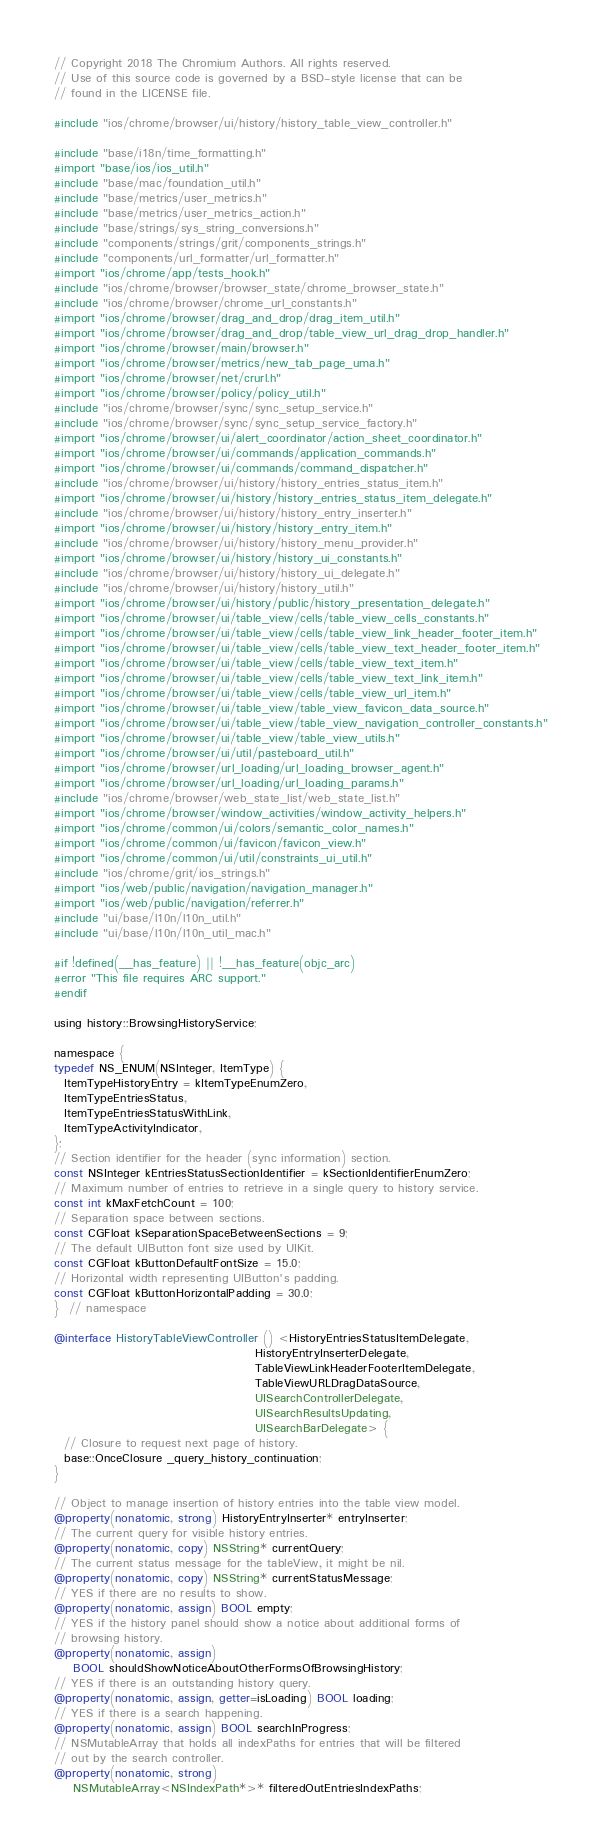<code> <loc_0><loc_0><loc_500><loc_500><_ObjectiveC_>// Copyright 2018 The Chromium Authors. All rights reserved.
// Use of this source code is governed by a BSD-style license that can be
// found in the LICENSE file.

#include "ios/chrome/browser/ui/history/history_table_view_controller.h"

#include "base/i18n/time_formatting.h"
#import "base/ios/ios_util.h"
#include "base/mac/foundation_util.h"
#include "base/metrics/user_metrics.h"
#include "base/metrics/user_metrics_action.h"
#include "base/strings/sys_string_conversions.h"
#include "components/strings/grit/components_strings.h"
#include "components/url_formatter/url_formatter.h"
#import "ios/chrome/app/tests_hook.h"
#include "ios/chrome/browser/browser_state/chrome_browser_state.h"
#include "ios/chrome/browser/chrome_url_constants.h"
#import "ios/chrome/browser/drag_and_drop/drag_item_util.h"
#import "ios/chrome/browser/drag_and_drop/table_view_url_drag_drop_handler.h"
#import "ios/chrome/browser/main/browser.h"
#import "ios/chrome/browser/metrics/new_tab_page_uma.h"
#import "ios/chrome/browser/net/crurl.h"
#import "ios/chrome/browser/policy/policy_util.h"
#include "ios/chrome/browser/sync/sync_setup_service.h"
#include "ios/chrome/browser/sync/sync_setup_service_factory.h"
#import "ios/chrome/browser/ui/alert_coordinator/action_sheet_coordinator.h"
#import "ios/chrome/browser/ui/commands/application_commands.h"
#import "ios/chrome/browser/ui/commands/command_dispatcher.h"
#include "ios/chrome/browser/ui/history/history_entries_status_item.h"
#import "ios/chrome/browser/ui/history/history_entries_status_item_delegate.h"
#include "ios/chrome/browser/ui/history/history_entry_inserter.h"
#import "ios/chrome/browser/ui/history/history_entry_item.h"
#include "ios/chrome/browser/ui/history/history_menu_provider.h"
#import "ios/chrome/browser/ui/history/history_ui_constants.h"
#include "ios/chrome/browser/ui/history/history_ui_delegate.h"
#include "ios/chrome/browser/ui/history/history_util.h"
#import "ios/chrome/browser/ui/history/public/history_presentation_delegate.h"
#import "ios/chrome/browser/ui/table_view/cells/table_view_cells_constants.h"
#import "ios/chrome/browser/ui/table_view/cells/table_view_link_header_footer_item.h"
#import "ios/chrome/browser/ui/table_view/cells/table_view_text_header_footer_item.h"
#import "ios/chrome/browser/ui/table_view/cells/table_view_text_item.h"
#import "ios/chrome/browser/ui/table_view/cells/table_view_text_link_item.h"
#import "ios/chrome/browser/ui/table_view/cells/table_view_url_item.h"
#import "ios/chrome/browser/ui/table_view/table_view_favicon_data_source.h"
#import "ios/chrome/browser/ui/table_view/table_view_navigation_controller_constants.h"
#import "ios/chrome/browser/ui/table_view/table_view_utils.h"
#import "ios/chrome/browser/ui/util/pasteboard_util.h"
#import "ios/chrome/browser/url_loading/url_loading_browser_agent.h"
#import "ios/chrome/browser/url_loading/url_loading_params.h"
#include "ios/chrome/browser/web_state_list/web_state_list.h"
#import "ios/chrome/browser/window_activities/window_activity_helpers.h"
#import "ios/chrome/common/ui/colors/semantic_color_names.h"
#import "ios/chrome/common/ui/favicon/favicon_view.h"
#import "ios/chrome/common/ui/util/constraints_ui_util.h"
#include "ios/chrome/grit/ios_strings.h"
#import "ios/web/public/navigation/navigation_manager.h"
#import "ios/web/public/navigation/referrer.h"
#include "ui/base/l10n/l10n_util.h"
#include "ui/base/l10n/l10n_util_mac.h"

#if !defined(__has_feature) || !__has_feature(objc_arc)
#error "This file requires ARC support."
#endif

using history::BrowsingHistoryService;

namespace {
typedef NS_ENUM(NSInteger, ItemType) {
  ItemTypeHistoryEntry = kItemTypeEnumZero,
  ItemTypeEntriesStatus,
  ItemTypeEntriesStatusWithLink,
  ItemTypeActivityIndicator,
};
// Section identifier for the header (sync information) section.
const NSInteger kEntriesStatusSectionIdentifier = kSectionIdentifierEnumZero;
// Maximum number of entries to retrieve in a single query to history service.
const int kMaxFetchCount = 100;
// Separation space between sections.
const CGFloat kSeparationSpaceBetweenSections = 9;
// The default UIButton font size used by UIKit.
const CGFloat kButtonDefaultFontSize = 15.0;
// Horizontal width representing UIButton's padding.
const CGFloat kButtonHorizontalPadding = 30.0;
}  // namespace

@interface HistoryTableViewController () <HistoryEntriesStatusItemDelegate,
                                          HistoryEntryInserterDelegate,
                                          TableViewLinkHeaderFooterItemDelegate,
                                          TableViewURLDragDataSource,
                                          UISearchControllerDelegate,
                                          UISearchResultsUpdating,
                                          UISearchBarDelegate> {
  // Closure to request next page of history.
  base::OnceClosure _query_history_continuation;
}

// Object to manage insertion of history entries into the table view model.
@property(nonatomic, strong) HistoryEntryInserter* entryInserter;
// The current query for visible history entries.
@property(nonatomic, copy) NSString* currentQuery;
// The current status message for the tableView, it might be nil.
@property(nonatomic, copy) NSString* currentStatusMessage;
// YES if there are no results to show.
@property(nonatomic, assign) BOOL empty;
// YES if the history panel should show a notice about additional forms of
// browsing history.
@property(nonatomic, assign)
    BOOL shouldShowNoticeAboutOtherFormsOfBrowsingHistory;
// YES if there is an outstanding history query.
@property(nonatomic, assign, getter=isLoading) BOOL loading;
// YES if there is a search happening.
@property(nonatomic, assign) BOOL searchInProgress;
// NSMutableArray that holds all indexPaths for entries that will be filtered
// out by the search controller.
@property(nonatomic, strong)
    NSMutableArray<NSIndexPath*>* filteredOutEntriesIndexPaths;</code> 